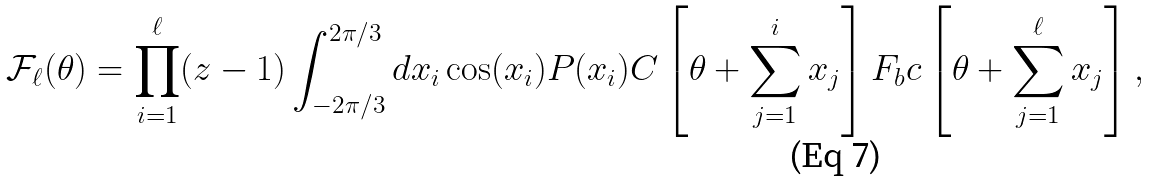Convert formula to latex. <formula><loc_0><loc_0><loc_500><loc_500>\mathcal { F } _ { \ell } ( \theta ) = \prod _ { i = 1 } ^ { \ell } ( z - 1 ) \int _ { - 2 \pi / 3 } ^ { 2 \pi / 3 } d x _ { i } \cos ( x _ { i } ) P ( x _ { i } ) C \left [ \theta + \sum _ { j = 1 } ^ { i } x _ { j } \right ] F _ { b } c \left [ \theta + \sum _ { j = 1 } ^ { \ell } x _ { j } \right ] ,</formula> 